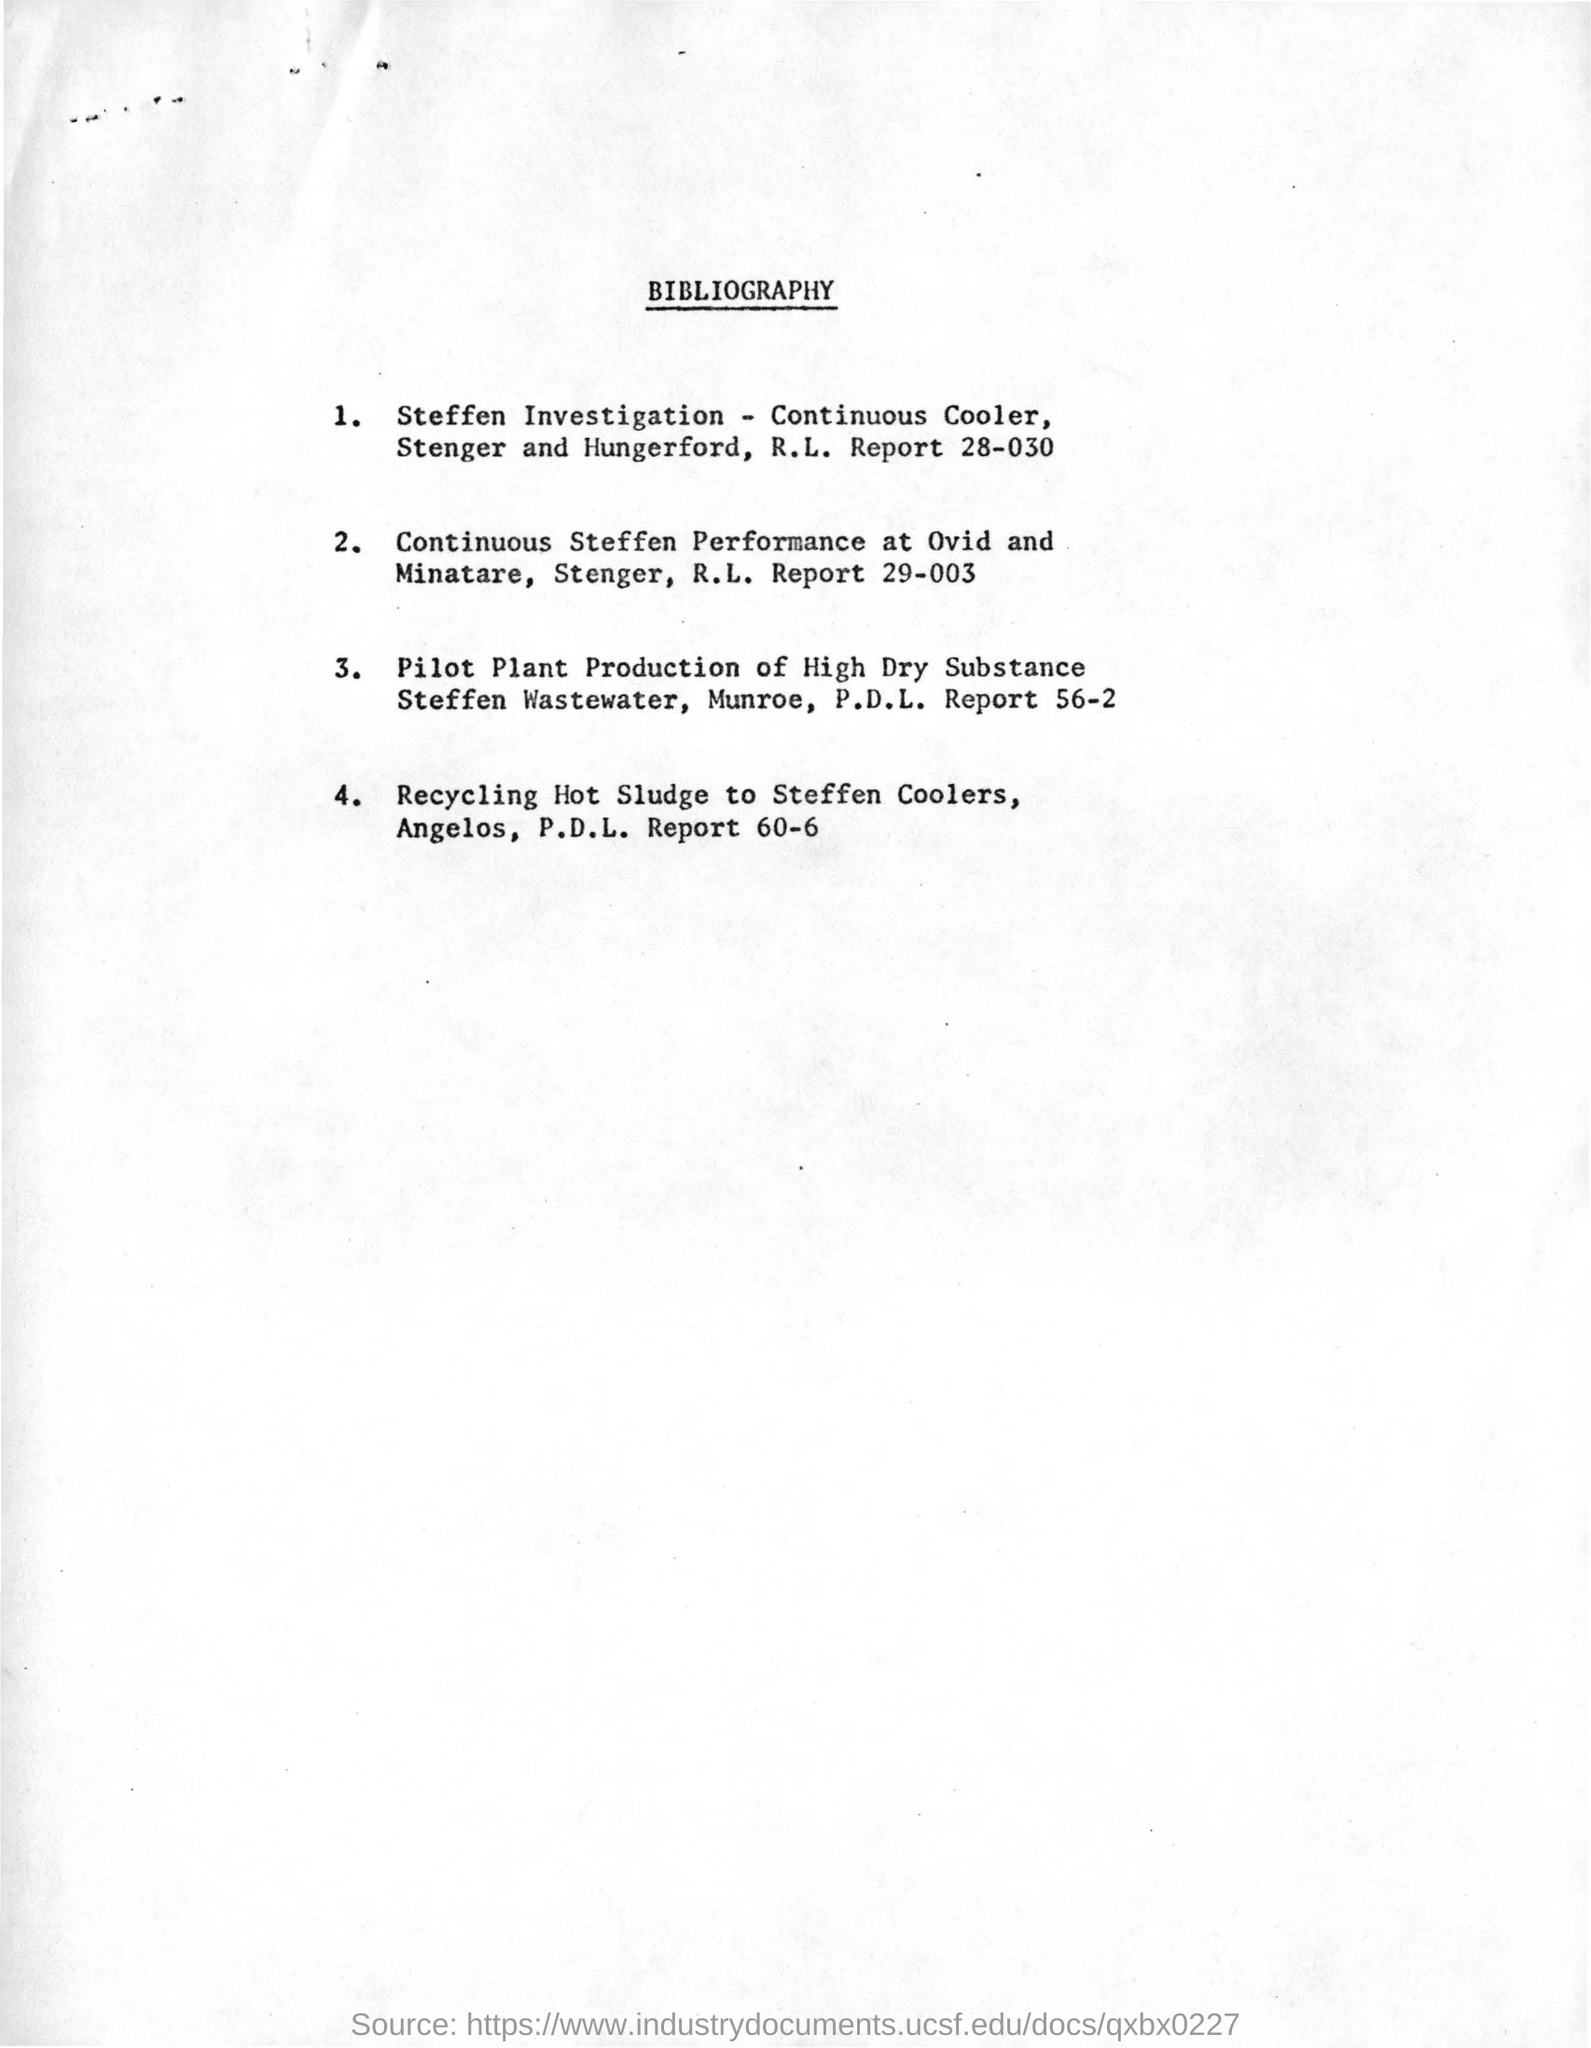Draw attention to some important aspects in this diagram. The title of this document is "The Importance of Citation in Academic Writing: A Comprehensive Guide for Students. 